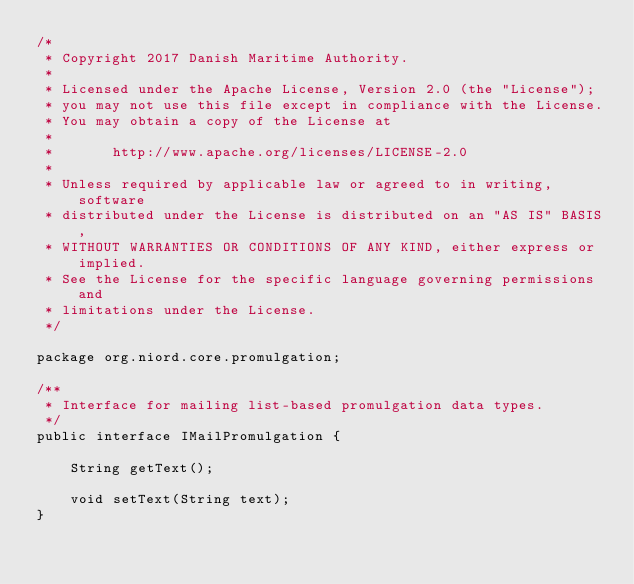<code> <loc_0><loc_0><loc_500><loc_500><_Java_>/*
 * Copyright 2017 Danish Maritime Authority.
 *
 * Licensed under the Apache License, Version 2.0 (the "License");
 * you may not use this file except in compliance with the License.
 * You may obtain a copy of the License at
 *
 *       http://www.apache.org/licenses/LICENSE-2.0
 *
 * Unless required by applicable law or agreed to in writing, software
 * distributed under the License is distributed on an "AS IS" BASIS,
 * WITHOUT WARRANTIES OR CONDITIONS OF ANY KIND, either express or implied.
 * See the License for the specific language governing permissions and
 * limitations under the License.
 */

package org.niord.core.promulgation;

/**
 * Interface for mailing list-based promulgation data types.
 */
public interface IMailPromulgation {

    String getText();

    void setText(String text);
}
</code> 